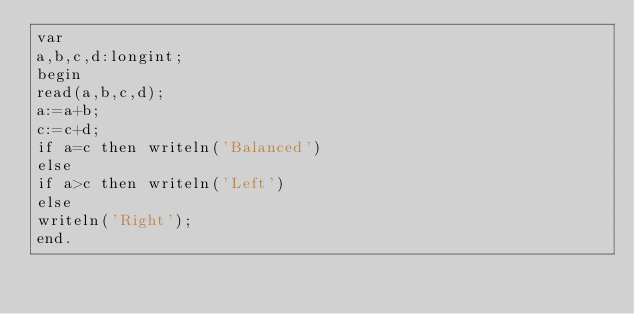<code> <loc_0><loc_0><loc_500><loc_500><_Pascal_>var
a,b,c,d:longint;
begin
read(a,b,c,d);
a:=a+b;
c:=c+d;
if a=c then writeln('Balanced')
else
if a>c then writeln('Left')
else
writeln('Right');
end.</code> 